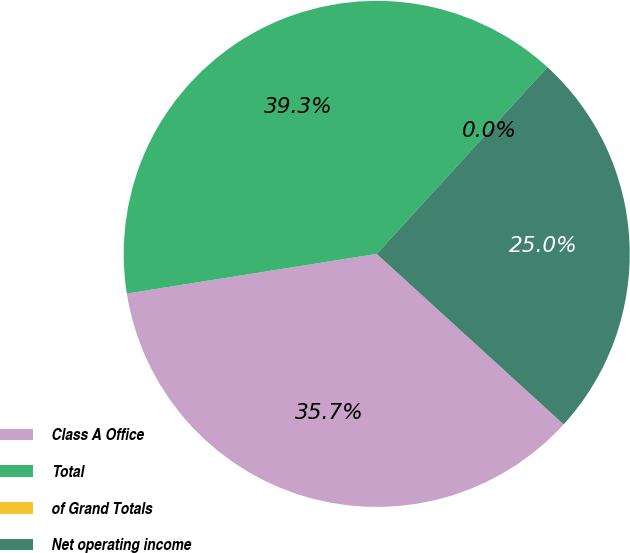Convert chart to OTSL. <chart><loc_0><loc_0><loc_500><loc_500><pie_chart><fcel>Class A Office<fcel>Total<fcel>of Grand Totals<fcel>Net operating income<nl><fcel>35.72%<fcel>39.29%<fcel>0.0%<fcel>24.98%<nl></chart> 